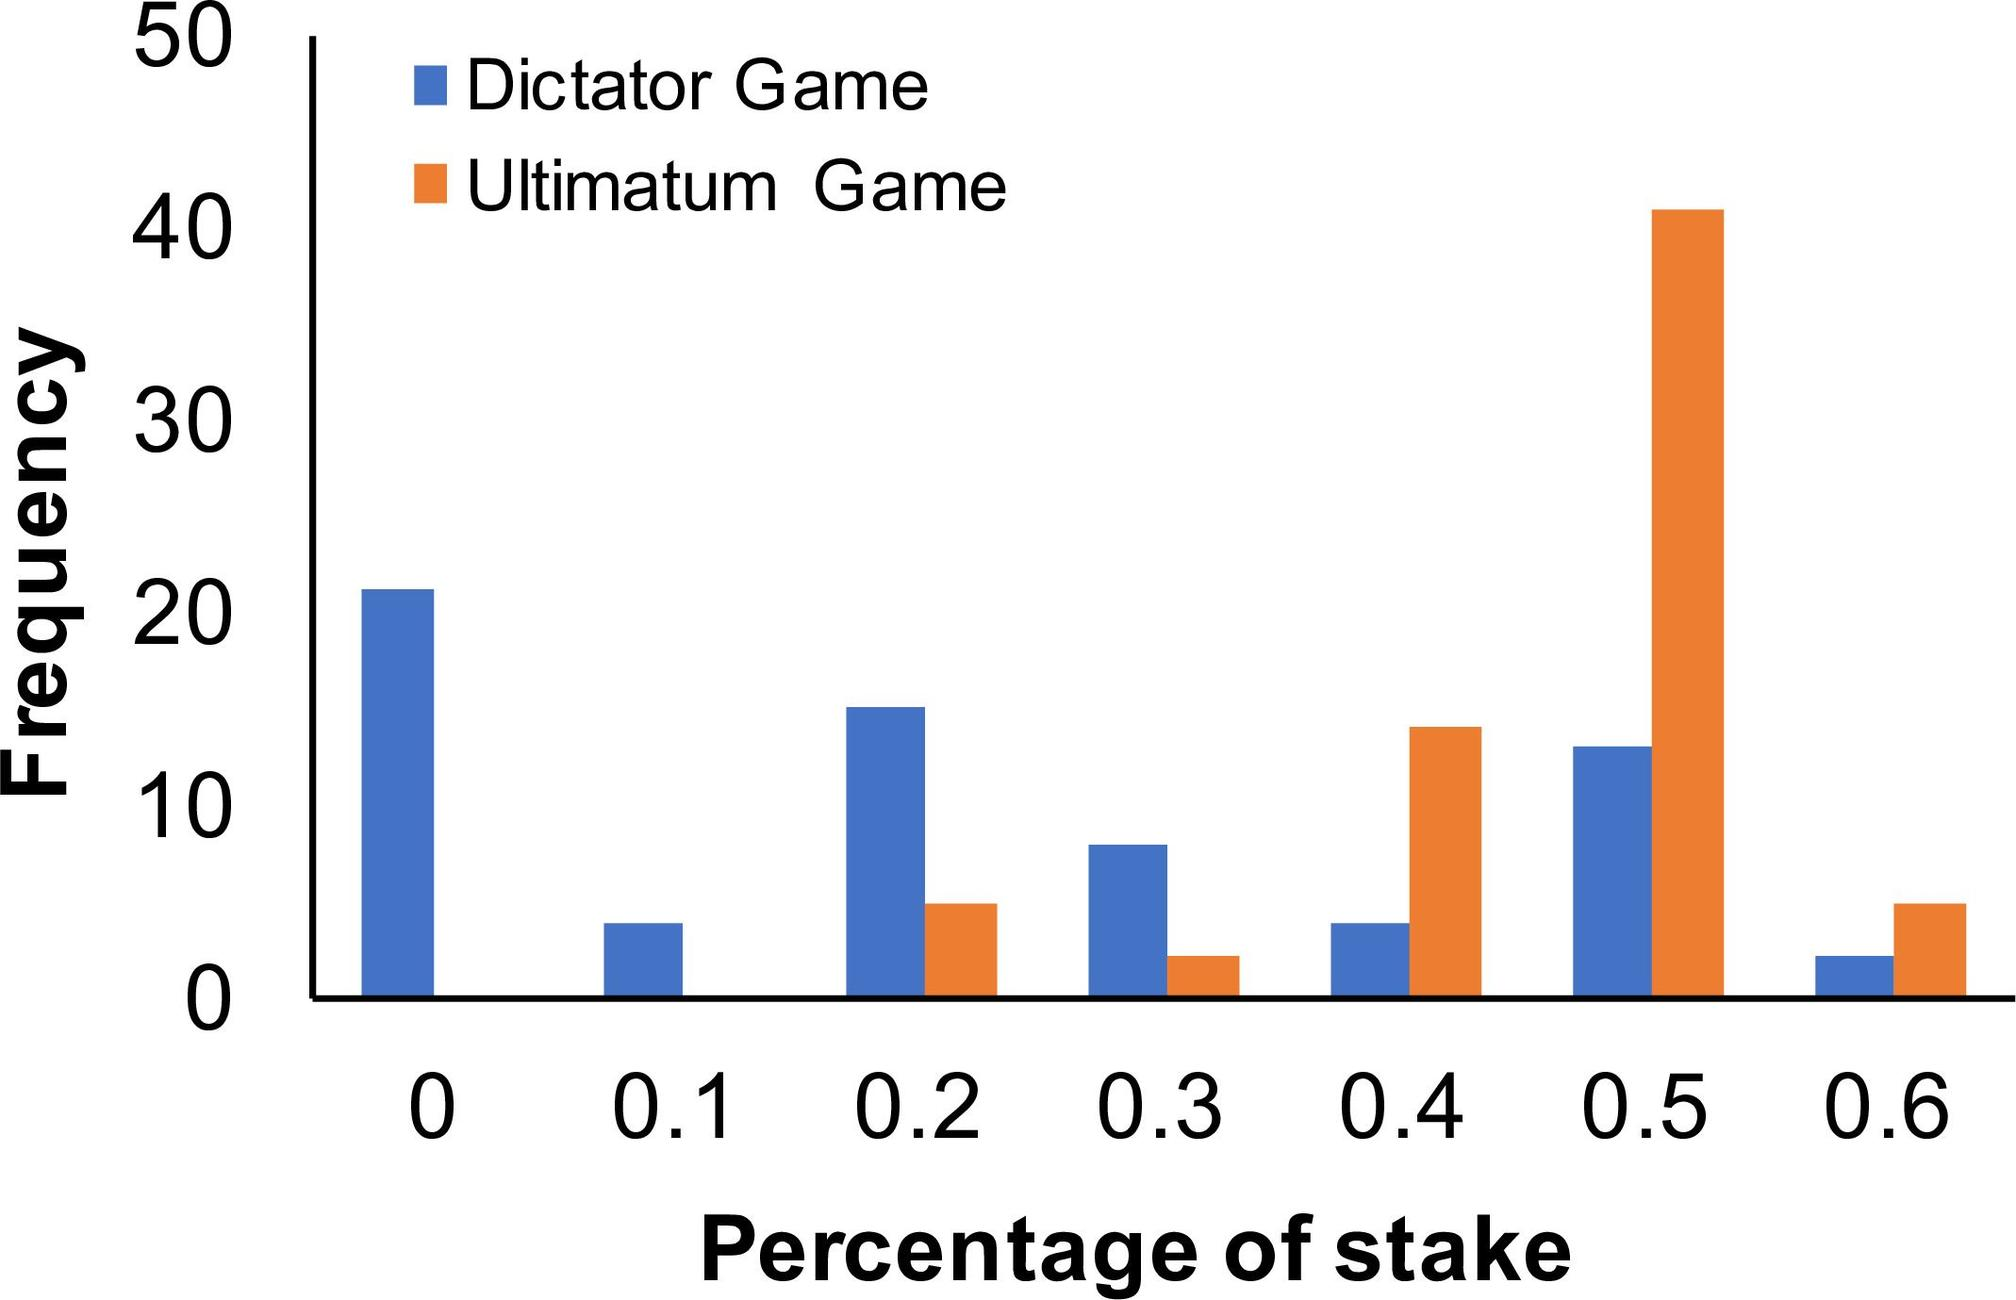What might be the reason behind the noticeable difference in offer frequencies at the 0.5 stake level between the Dictator Game and the Ultimatum Game? The significant difference in offer frequencies between the Dictator Game and the Ultimatum Game at the 0.5 stake level might be attributed to the strategic elements inherent in each game. In the Ultimatum Game, proposers might feel pressured to make fairer offers to avoid rejection, unlike in the Dictator Game, where the responder does not have the power to reject the offer. 